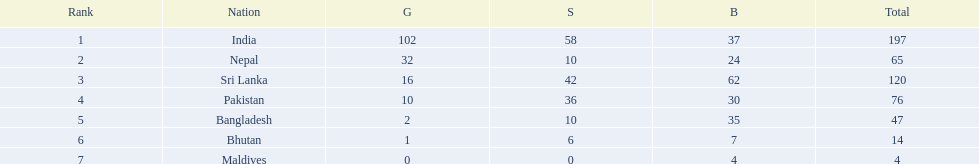Which countries won medals? India, Nepal, Sri Lanka, Pakistan, Bangladesh, Bhutan, Maldives. Which won the most? India. Which won the fewest? Maldives. 